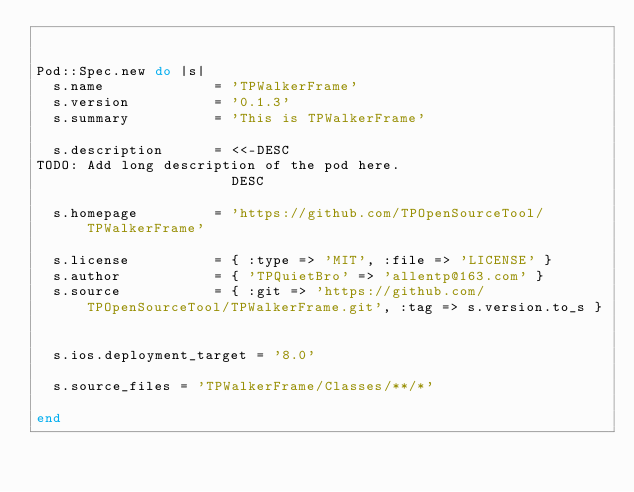Convert code to text. <code><loc_0><loc_0><loc_500><loc_500><_Ruby_>

Pod::Spec.new do |s|
  s.name             = 'TPWalkerFrame'
  s.version          = '0.1.3'
  s.summary          = 'This is TPWalkerFrame'

  s.description      = <<-DESC
TODO: Add long description of the pod here.
                       DESC

  s.homepage         = 'https://github.com/TPOpenSourceTool/TPWalkerFrame'

  s.license          = { :type => 'MIT', :file => 'LICENSE' }
  s.author           = { 'TPQuietBro' => 'allentp@163.com' }
  s.source           = { :git => 'https://github.com/TPOpenSourceTool/TPWalkerFrame.git', :tag => s.version.to_s }


  s.ios.deployment_target = '8.0'

  s.source_files = 'TPWalkerFrame/Classes/**/*'

end
</code> 